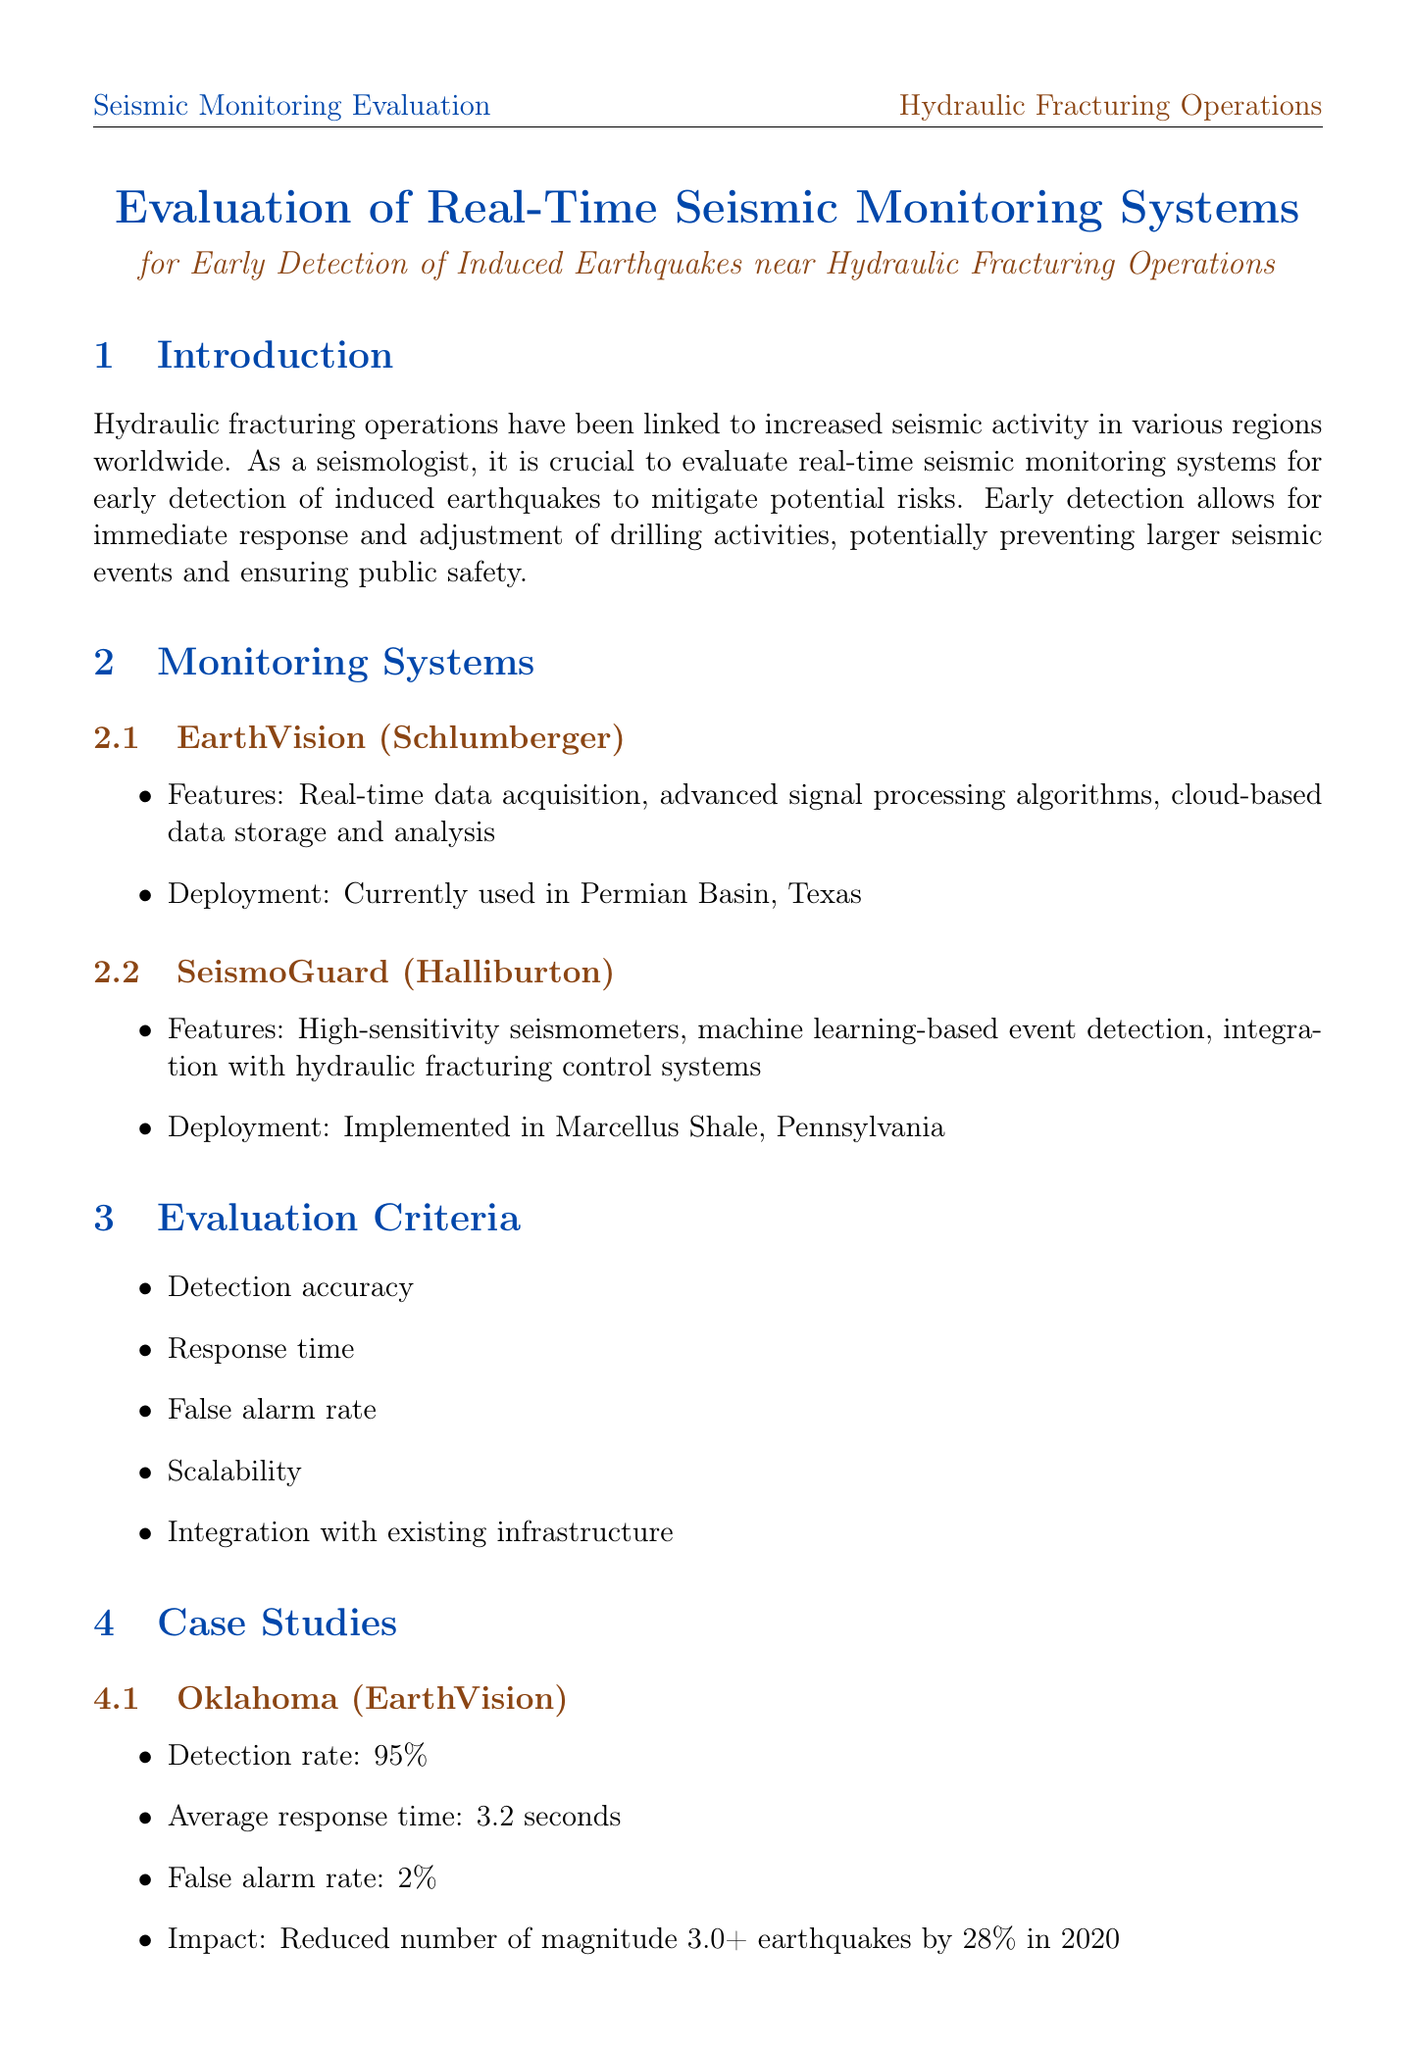What is the detection rate of SeismoGuard? SeismoGuard has a detection rate listed in the case study of Alberta, Canada.
Answer: 97% What is the average response time of the EarthVision system? The average response time is specified in the case study of Oklahoma for EarthVision.
Answer: 3.2 seconds What technology is suggested for improved understanding of surface deformation? The document lists technology developments, and InSAR data is mentioned specifically for this purpose.
Answer: Satellite-based InSAR data What is one major challenge mentioned in the report? The document outlines several challenges faced by monitoring systems, one of which is clearly stated.
Answer: Distinguishing between natural and induced seismicity How many potential induced earthquakes were prevented using SeismoGuard? The impact of SeismoGuard in 2021 includes a specific number of prevented earthquakes.
Answer: 15 What type of monitoring system is EarthVision classified as? The document specifies the features and deployment of EarthVision, indicating its purpose.
Answer: Real-time seismic monitoring system What impact did EarthVision have in Oklahoma in 2020? The document mentions a measurable impact regarding earthquake reduction in a specific year.
Answer: Reduced number of magnitude 3.0+ earthquakes by 28% in 2020 What research area is recommended for investment? The recommendations section indicates areas for potential investment to enhance monitoring systems.
Answer: Improving prediction models and early warning systems 